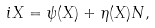<formula> <loc_0><loc_0><loc_500><loc_500>i X = \psi ( X ) + \eta ( X ) N ,</formula> 